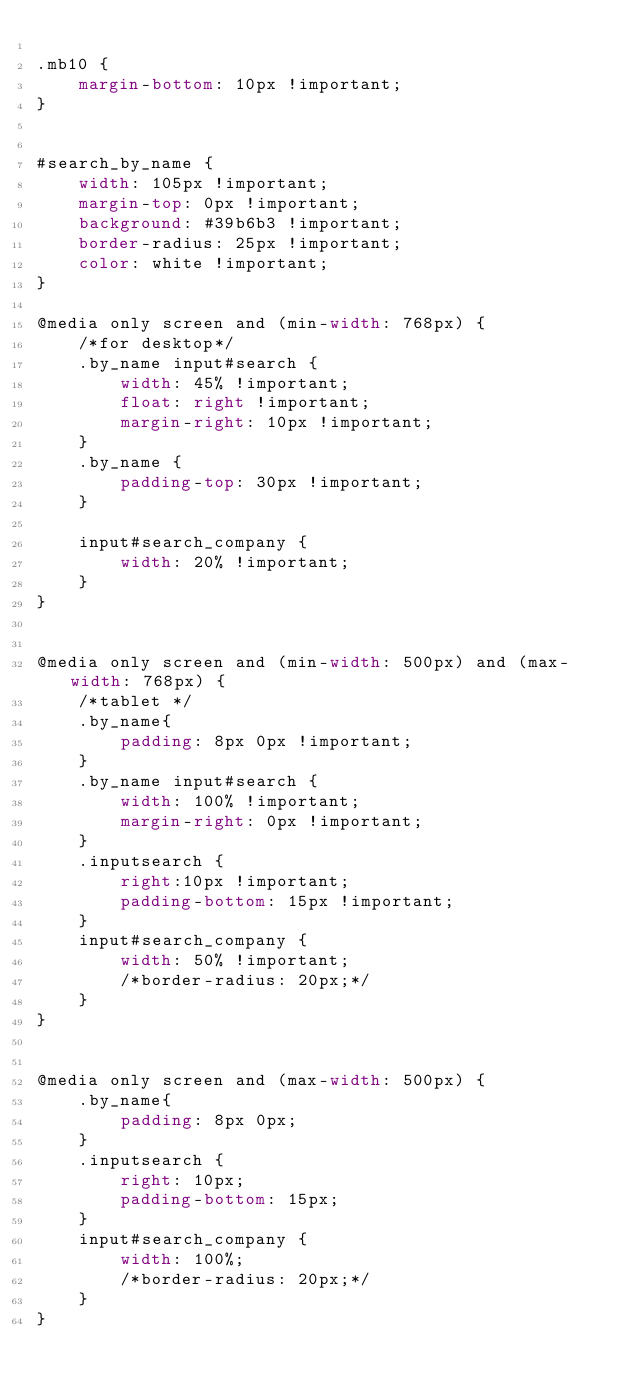<code> <loc_0><loc_0><loc_500><loc_500><_CSS_>
.mb10 {
	margin-bottom: 10px !important;
}


#search_by_name {  
	width: 105px !important;
	margin-top: 0px !important;
    background: #39b6b3 !important;
    border-radius: 25px !important;
    color: white !important;
}

@media only screen and (min-width: 768px) {
	/*for desktop*/
	.by_name input#search {
		width: 45% !important;
		float: right !important;
		margin-right: 10px !important;
	}
	.by_name {
	    padding-top: 30px !important;
	}

	input#search_company {
	    width: 20% !important;
	}
}


@media only screen and (min-width: 500px) and (max-width: 768px) { 
	/*tablet */
	.by_name{
		padding: 8px 0px !important;
	}	
	.by_name input#search {
		width: 100% !important;	
		margin-right: 0px !important;	
	}
	.inputsearch {
	    right:10px !important;
	    padding-bottom: 15px !important;
	}
	input#search_company {
	    width: 50% !important;
	    /*border-radius: 20px;*/
	}
}


@media only screen and (max-width: 500px) {
	.by_name{
		padding: 8px 0px;
	}
	.inputsearch {
	    right: 10px;
	    padding-bottom: 15px;
	}
	input#search_company {
	    width: 100%;
	    /*border-radius: 20px;*/
	}
} </code> 